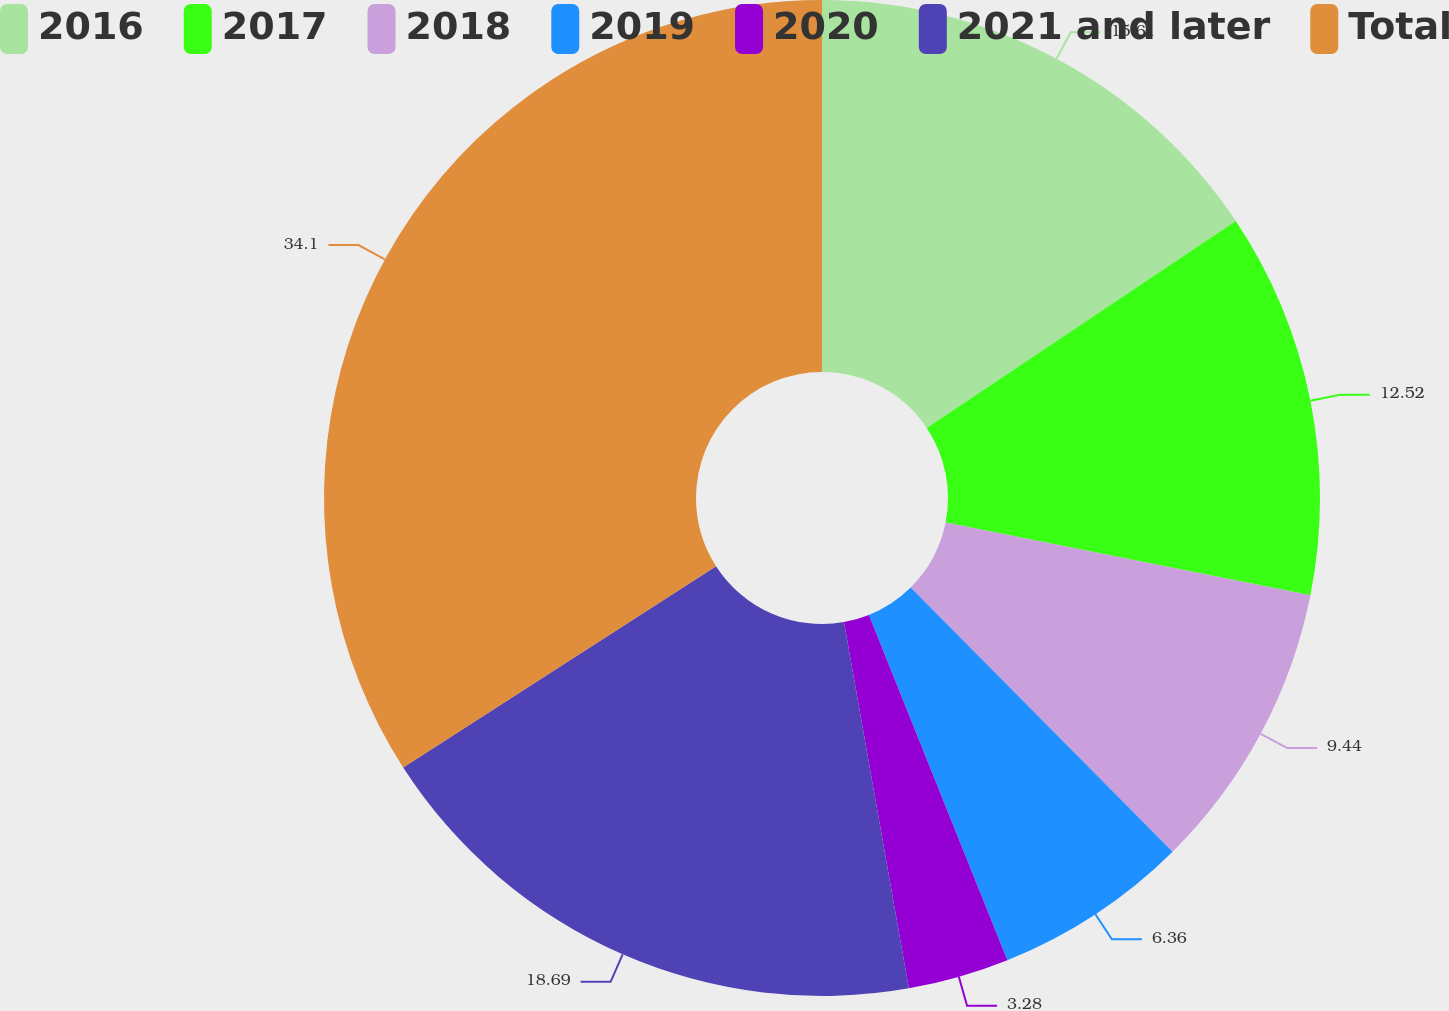Convert chart. <chart><loc_0><loc_0><loc_500><loc_500><pie_chart><fcel>2016<fcel>2017<fcel>2018<fcel>2019<fcel>2020<fcel>2021 and later<fcel>Total<nl><fcel>15.61%<fcel>12.52%<fcel>9.44%<fcel>6.36%<fcel>3.28%<fcel>18.69%<fcel>34.1%<nl></chart> 